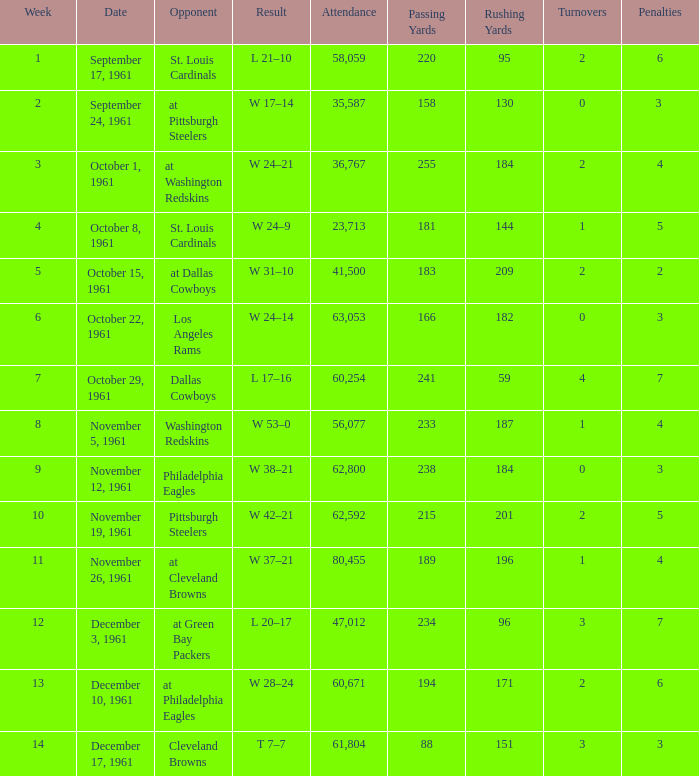What was the result on october 8, 1961? W 24–9. Would you mind parsing the complete table? {'header': ['Week', 'Date', 'Opponent', 'Result', 'Attendance', 'Passing Yards', 'Rushing Yards', 'Turnovers', 'Penalties'], 'rows': [['1', 'September 17, 1961', 'St. Louis Cardinals', 'L 21–10', '58,059', '220', '95', '2', '6'], ['2', 'September 24, 1961', 'at Pittsburgh Steelers', 'W 17–14', '35,587', '158', '130', '0', '3 '], ['3', 'October 1, 1961', 'at Washington Redskins', 'W 24–21', '36,767', '255', '184', '2', '4'], ['4', 'October 8, 1961', 'St. Louis Cardinals', 'W 24–9', '23,713', '181', '144', '1', '5'], ['5', 'October 15, 1961', 'at Dallas Cowboys', 'W 31–10', '41,500', '183', '209', '2', '2'], ['6', 'October 22, 1961', 'Los Angeles Rams', 'W 24–14', '63,053', '166', '182', '0', '3'], ['7', 'October 29, 1961', 'Dallas Cowboys', 'L 17–16', '60,254', '241', '59', '4', '7'], ['8', 'November 5, 1961', 'Washington Redskins', 'W 53–0', '56,077', '233', '187', '1', '4'], ['9', 'November 12, 1961', 'Philadelphia Eagles', 'W 38–21', '62,800', '238', '184', '0', '3'], ['10', 'November 19, 1961', 'Pittsburgh Steelers', 'W 42–21', '62,592', '215', '201', '2', '5'], ['11', 'November 26, 1961', 'at Cleveland Browns', 'W 37–21', '80,455', '189', '196', '1', '4'], ['12', 'December 3, 1961', 'at Green Bay Packers', 'L 20–17', '47,012', '234', '96', '3', '7'], ['13', 'December 10, 1961', 'at Philadelphia Eagles', 'W 28–24', '60,671', '194', '171', '2', '6'], ['14', 'December 17, 1961', 'Cleveland Browns', 'T 7–7', '61,804', '88', '151', '3', '3']]} 